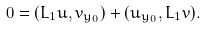<formula> <loc_0><loc_0><loc_500><loc_500>0 = ( L _ { 1 } u , v _ { y _ { 0 } } ) + ( u _ { y _ { 0 } } , L _ { 1 } v ) .</formula> 